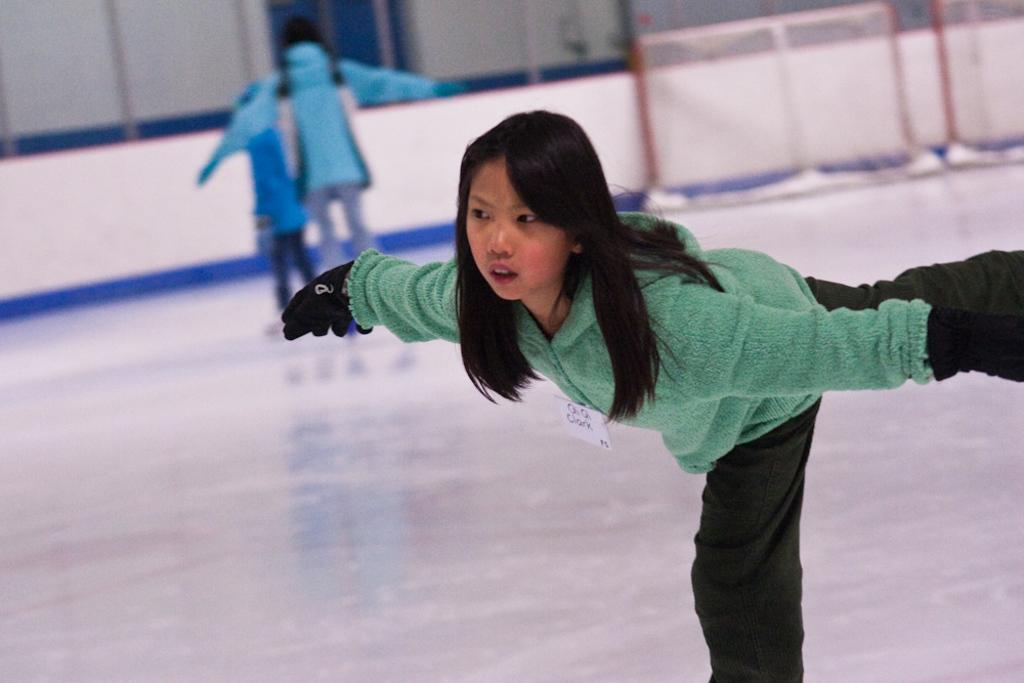What are the persons in the image doing? The persons in the image are skating. Can you describe the attire of one of the persons? One person is wearing a green and black color dress. What can be seen in the background of the image? There is white-colored fencing in the background of the image. What news headline is being discussed by the skaters in the image? There is no indication in the image that the skaters are discussing any news headlines. 